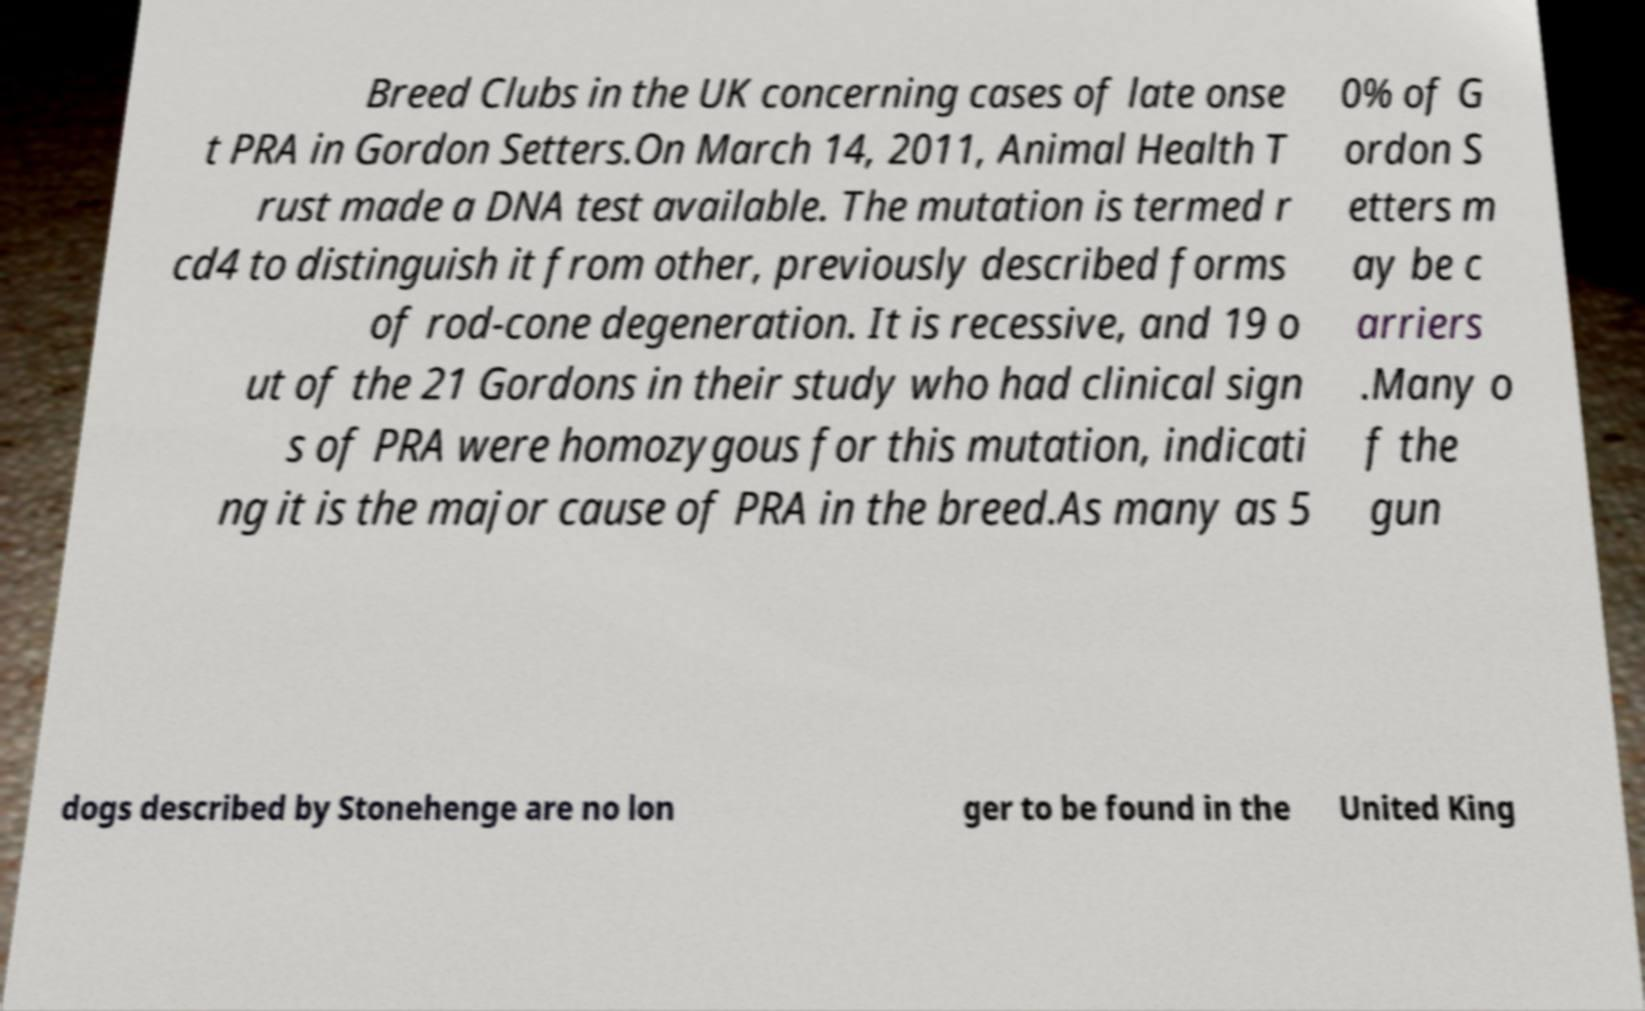Can you read and provide the text displayed in the image?This photo seems to have some interesting text. Can you extract and type it out for me? Breed Clubs in the UK concerning cases of late onse t PRA in Gordon Setters.On March 14, 2011, Animal Health T rust made a DNA test available. The mutation is termed r cd4 to distinguish it from other, previously described forms of rod-cone degeneration. It is recessive, and 19 o ut of the 21 Gordons in their study who had clinical sign s of PRA were homozygous for this mutation, indicati ng it is the major cause of PRA in the breed.As many as 5 0% of G ordon S etters m ay be c arriers .Many o f the gun dogs described by Stonehenge are no lon ger to be found in the United King 